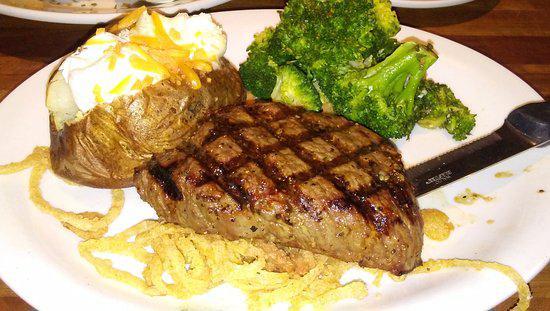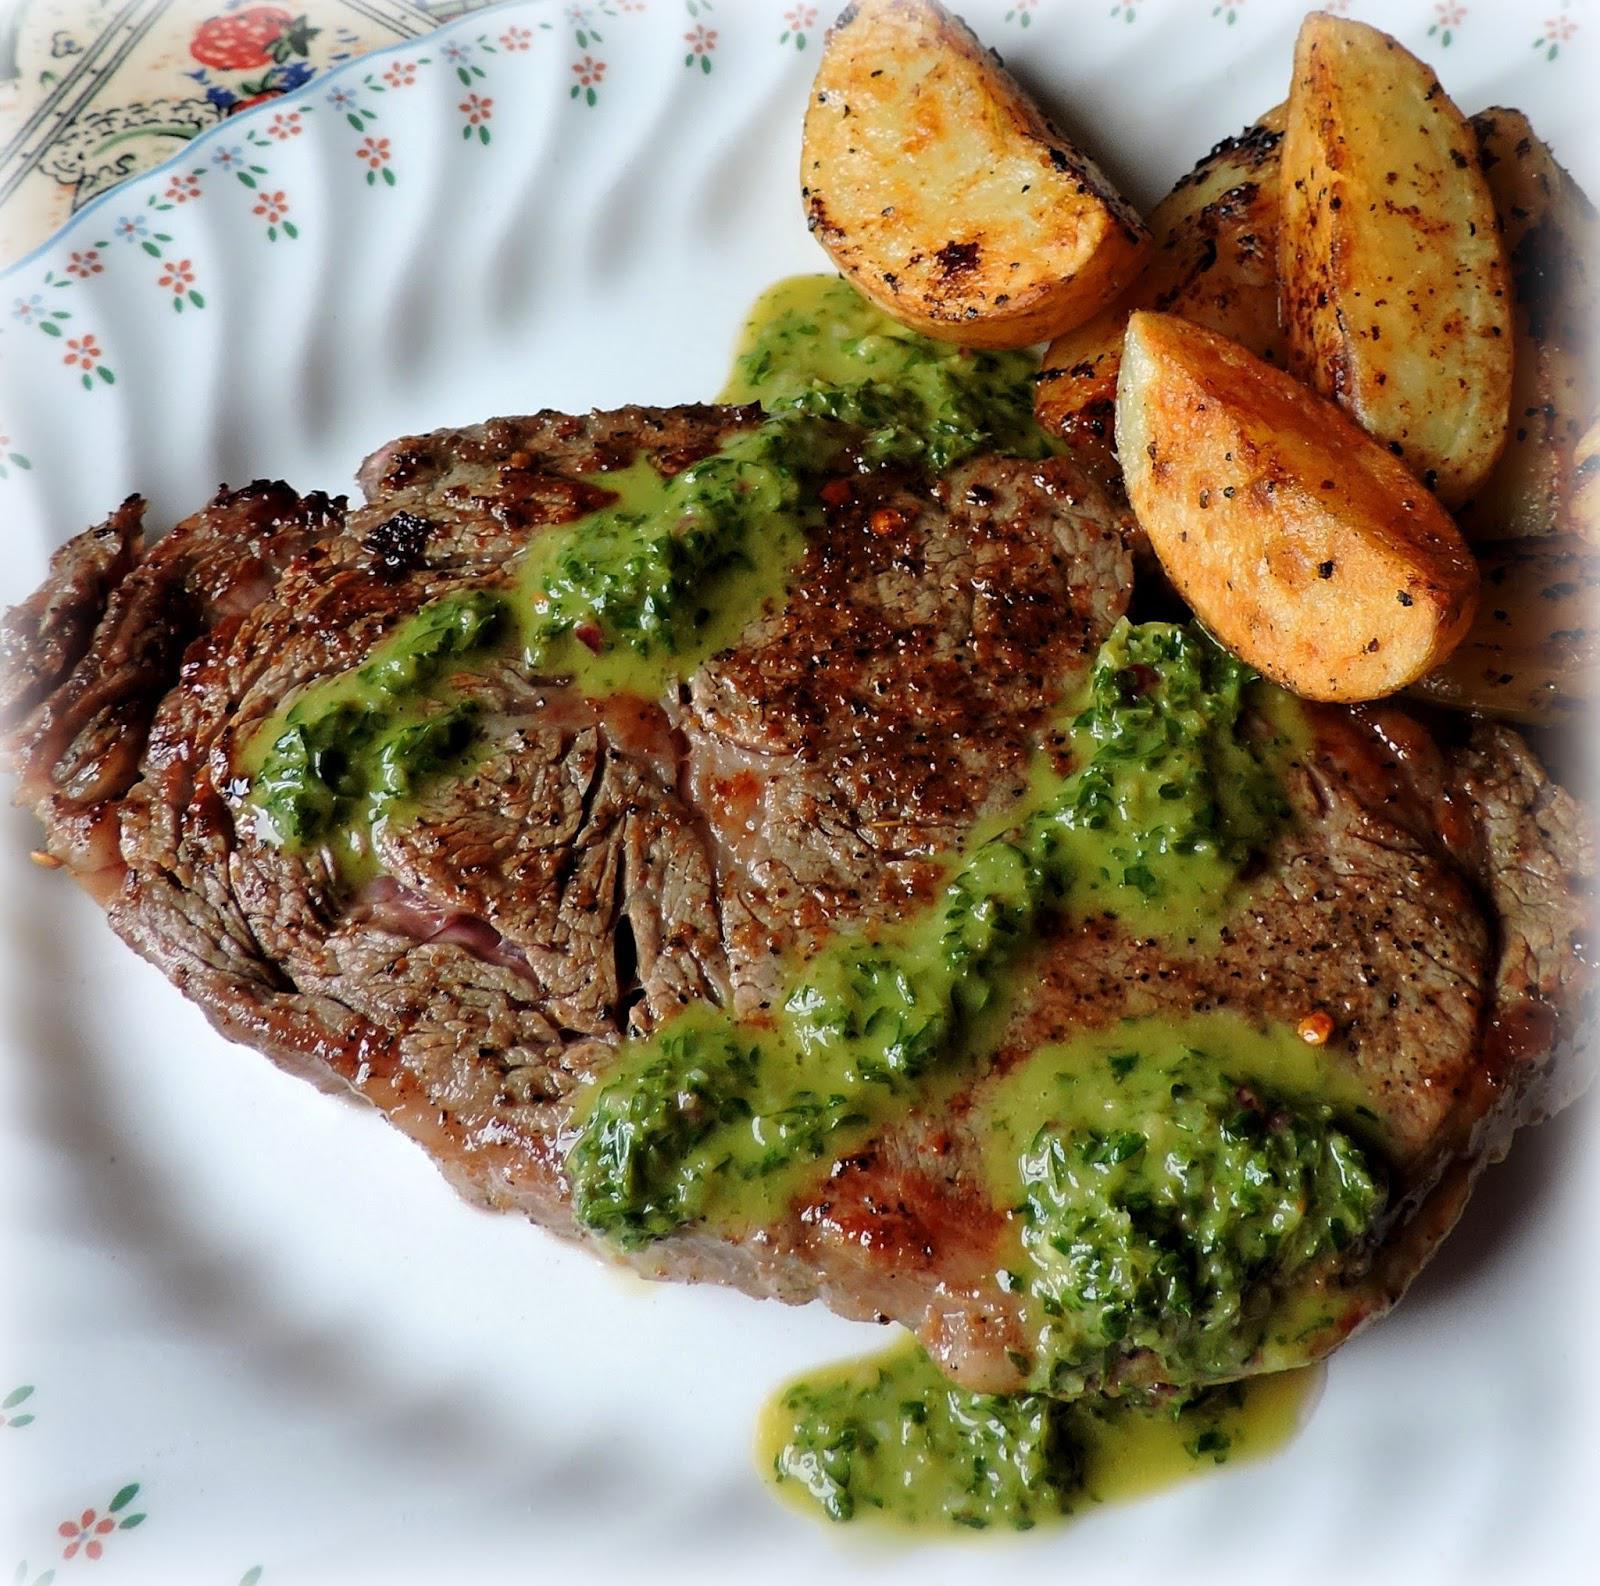The first image is the image on the left, the second image is the image on the right. Analyze the images presented: Is the assertion "There are carrots on the plate in the image on the left." valid? Answer yes or no. No. 